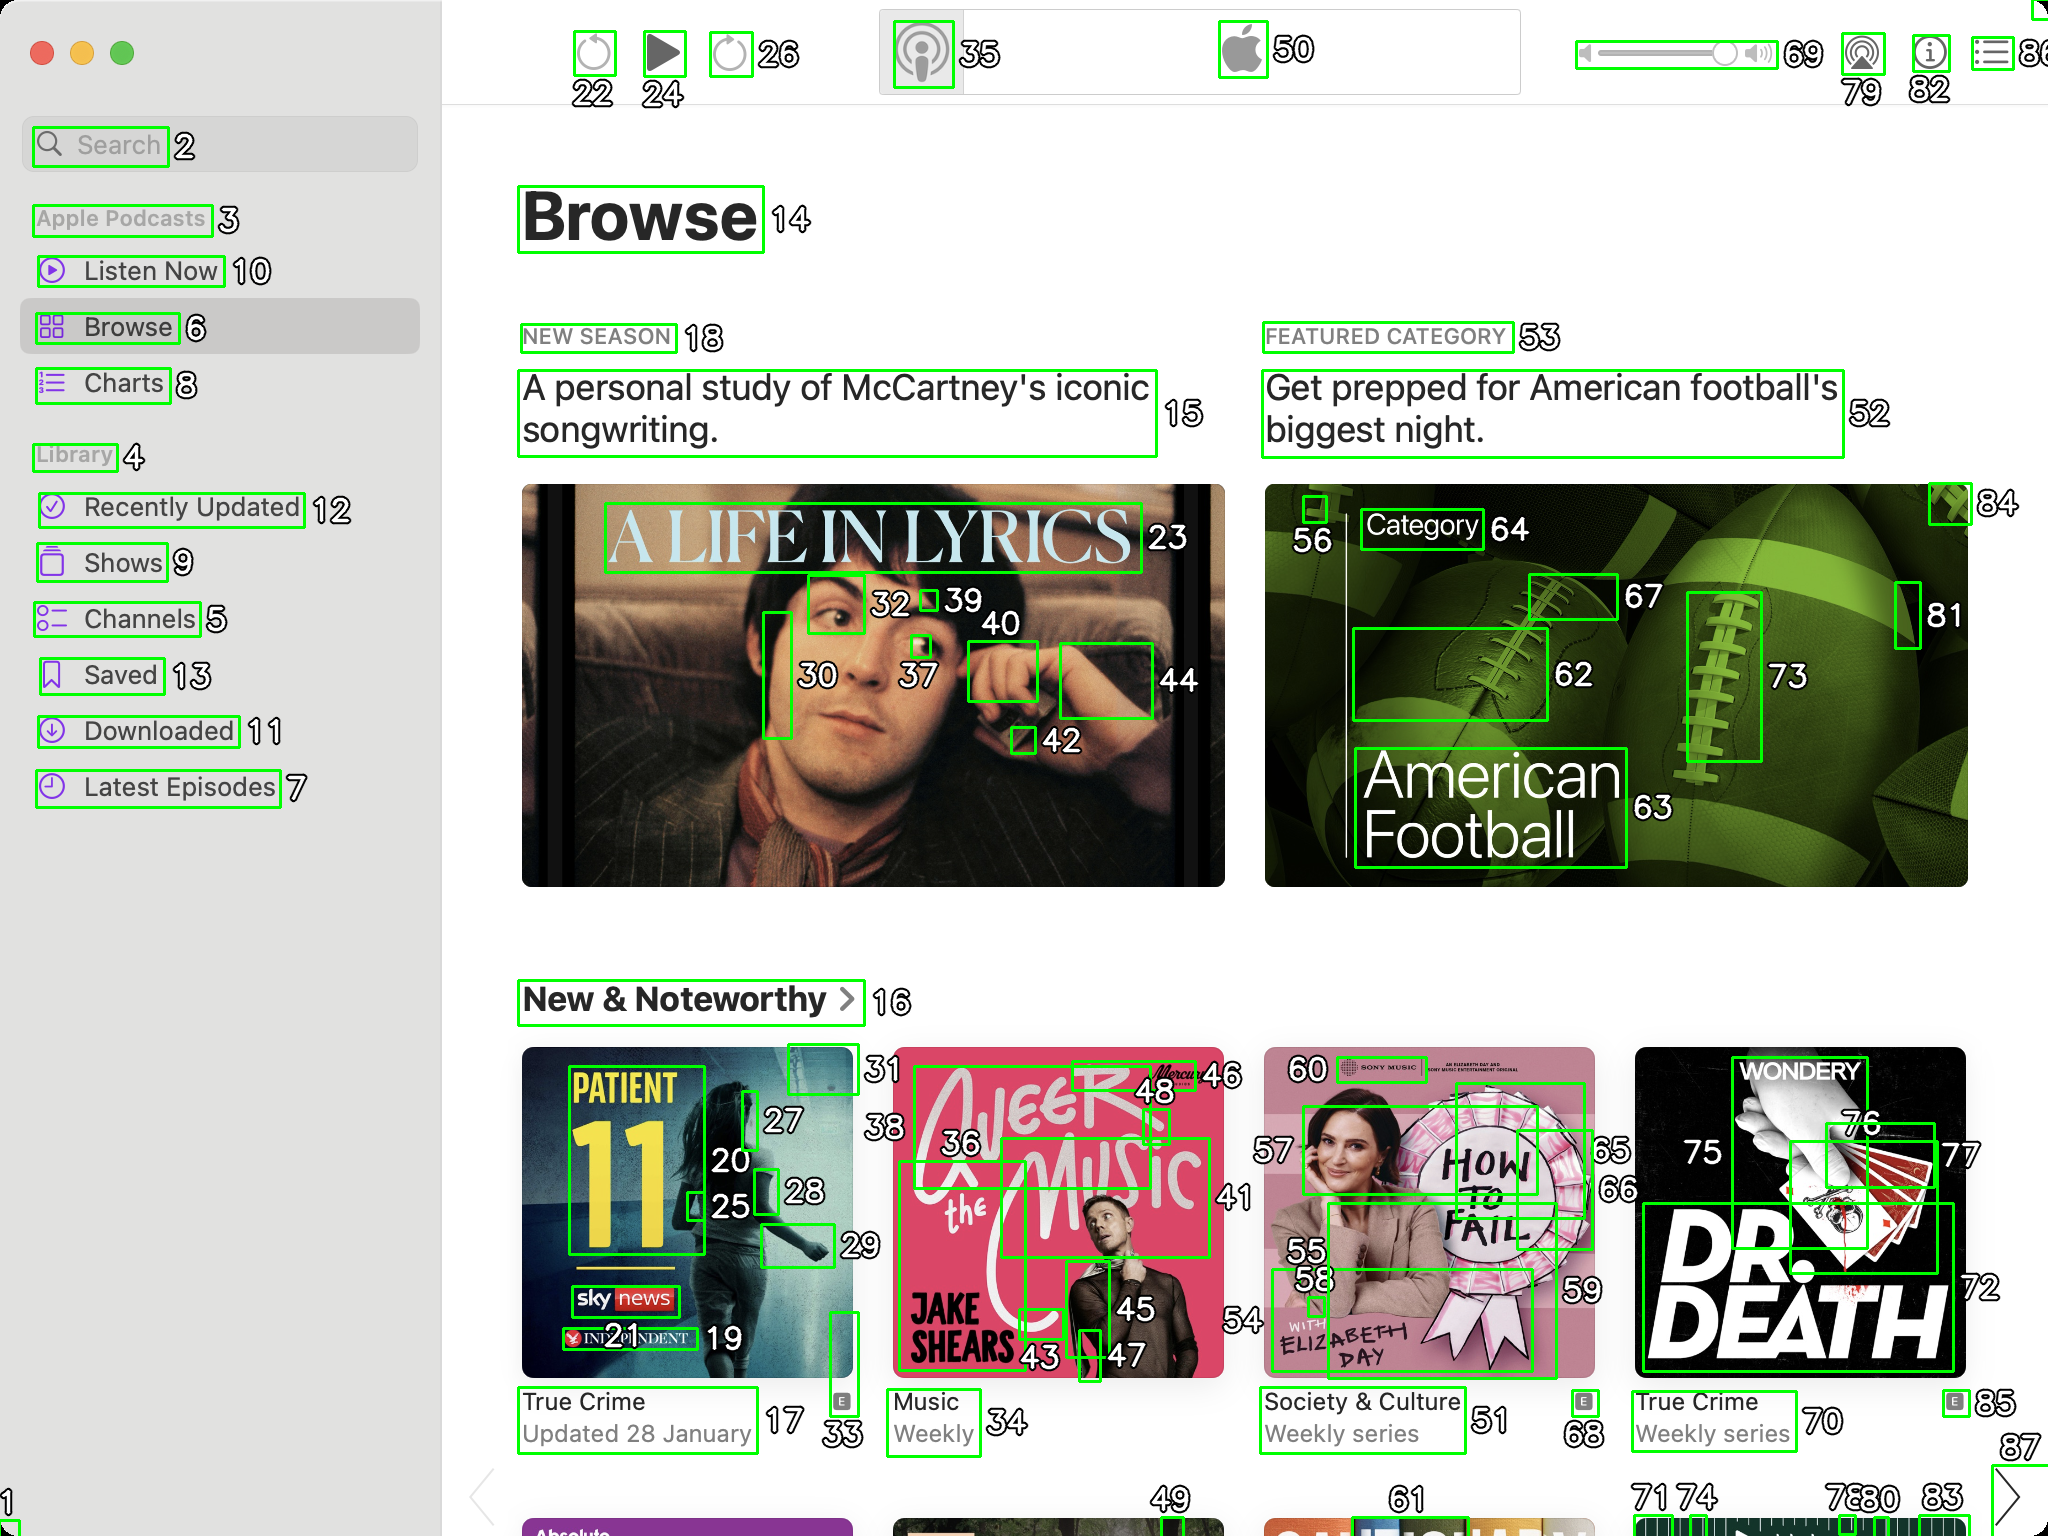You are an AI designed for image processing and segmentation analysis, particularly skilled in merging segmented regions of an image to improve accuracy and readability.

**Task Description:**
Your task is to address a user's concern with a UI screenshot of the Apple Podcasts application on MacOS. The screenshot contains multiple green boxes, each representing a UI element, with a unique white number outlined in black ranging from 1 to 88. Due to segmentation issues, some boxes that belong to the same UI element are divided unnaturally.

**Objective:**
Merge these segmented areas that correspond to a single UI element to create a coherent representation. The final output should be in JSON format, where each key-value pair represents the merged areas.
**Example JSON Output:**
If boxes with numbers 1, 2, and 3 should belong to the same UI element, the JSON output should be:

```json
{
    "UI Element 1": [1, 2, 3]
}
```

**Instructions:**

- **Identify Segmented Regions:** Analyze the screenshot to identify which green boxes belong to the same UI element.
- **Merge Regions:** Group the numbers of these boxes together to represent a single UI element.
- **Output Format:** Produce the output in JSON format, with each key representing a UI element and each value being a list of the numbers of the merged boxes.

**Primary Objective:**
Ensure the accuracy of the merged regions based on the user's supplied image information, maintaining the integrity and structure of the UI elements in the Apple Podcasts application on MacOS. Make sure that you merged only simple UI elements like images, text, inputs and so on, but not navbars, menus and sections. Here's a JSON representation of the merged UI elements based on the provided screenshot:

```json
{
    "UI Element 1": [22, 24, 26],
    "UI Element 2": [30, 37, 39, 40, 42, 44],
    "UI Element 3": [32, 34],
    "UI Element 4": [56, 62, 63, 64, 67, 73, 81],
    "UI Element 5": [20, 25, 27, 28, 33],
    "UI Element 6": [36, 43, 45, 46, 48],
    "UI Element 7": [55, 58, 59, 60],
    "UI Element 8": [75, 76, 77, 72]
}
```

Explanation:
- **UI Element 1** combines buttons for "Search," "Play," and other actions at the top of the application.
- **UI Element 2** is the image and text for "A Life in Lyrics."
- **UI Element 3** groups elements related to "Browse" heading.
- **UI Element 4** is the featured category "American Football" section.
- **UI Element 5** combines elements of the first podcast under "New & Noteworthy."
- **UI Element 6** groups elements related to the second podcast "Jake's Music."
- **UI Element 7** is the podcast "How to Fail" section.
- **UI Element 8** is the podcast "Dr. Death" section.

This segmentation aims to merge boxes that are part of the same visual element or closely related elements, improving the logical grouping and readability of the UI. 